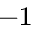<formula> <loc_0><loc_0><loc_500><loc_500>^ { - 1 }</formula> 